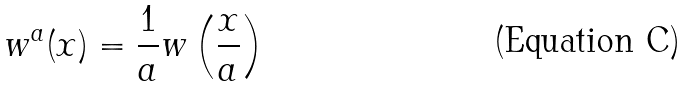Convert formula to latex. <formula><loc_0><loc_0><loc_500><loc_500>w ^ { a } ( x ) = \frac { 1 } { a } w \left ( \frac { x } { a } \right )</formula> 